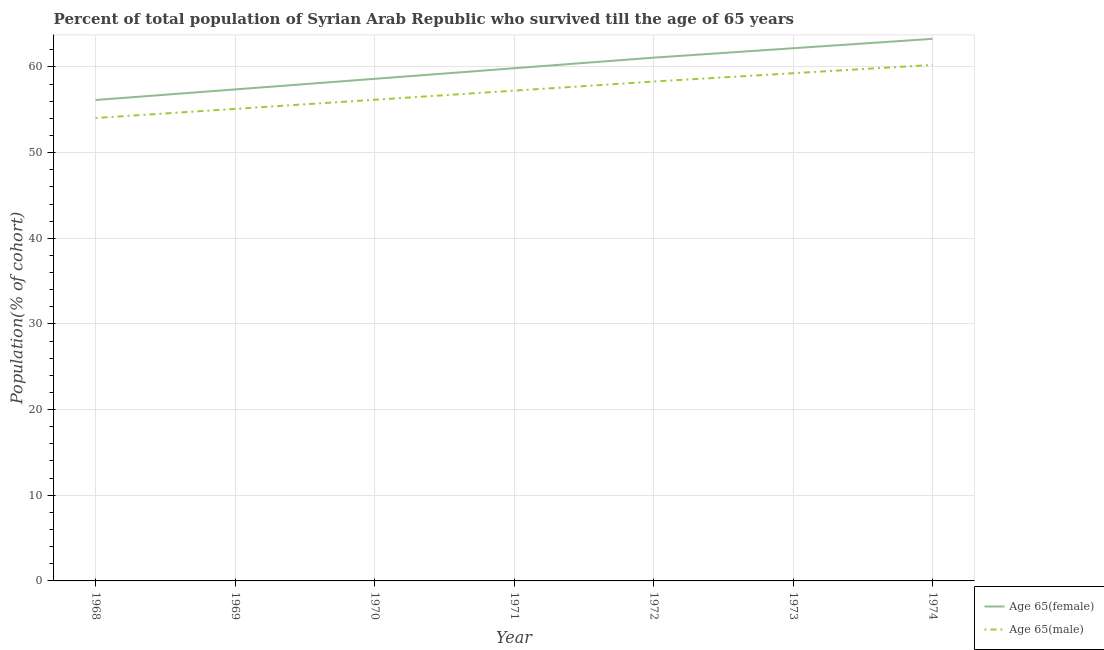Is the number of lines equal to the number of legend labels?
Provide a succinct answer. Yes. What is the percentage of male population who survived till age of 65 in 1974?
Provide a short and direct response. 60.24. Across all years, what is the maximum percentage of female population who survived till age of 65?
Provide a short and direct response. 63.28. Across all years, what is the minimum percentage of female population who survived till age of 65?
Your answer should be very brief. 56.14. In which year was the percentage of male population who survived till age of 65 maximum?
Your answer should be very brief. 1974. In which year was the percentage of male population who survived till age of 65 minimum?
Your response must be concise. 1968. What is the total percentage of female population who survived till age of 65 in the graph?
Your answer should be compact. 418.53. What is the difference between the percentage of male population who survived till age of 65 in 1972 and that in 1973?
Your answer should be very brief. -0.97. What is the difference between the percentage of female population who survived till age of 65 in 1971 and the percentage of male population who survived till age of 65 in 1970?
Provide a succinct answer. 3.68. What is the average percentage of female population who survived till age of 65 per year?
Provide a short and direct response. 59.79. In the year 1968, what is the difference between the percentage of male population who survived till age of 65 and percentage of female population who survived till age of 65?
Make the answer very short. -2.1. In how many years, is the percentage of male population who survived till age of 65 greater than 24 %?
Provide a short and direct response. 7. What is the ratio of the percentage of male population who survived till age of 65 in 1968 to that in 1969?
Provide a short and direct response. 0.98. Is the percentage of female population who survived till age of 65 in 1970 less than that in 1972?
Offer a very short reply. Yes. What is the difference between the highest and the second highest percentage of male population who survived till age of 65?
Offer a very short reply. 0.97. What is the difference between the highest and the lowest percentage of female population who survived till age of 65?
Your response must be concise. 7.14. In how many years, is the percentage of male population who survived till age of 65 greater than the average percentage of male population who survived till age of 65 taken over all years?
Provide a short and direct response. 4. Is the sum of the percentage of female population who survived till age of 65 in 1968 and 1970 greater than the maximum percentage of male population who survived till age of 65 across all years?
Your answer should be very brief. Yes. Does the percentage of female population who survived till age of 65 monotonically increase over the years?
Give a very brief answer. Yes. Is the percentage of female population who survived till age of 65 strictly greater than the percentage of male population who survived till age of 65 over the years?
Keep it short and to the point. Yes. Is the percentage of male population who survived till age of 65 strictly less than the percentage of female population who survived till age of 65 over the years?
Your answer should be compact. Yes. What is the difference between two consecutive major ticks on the Y-axis?
Provide a succinct answer. 10. Does the graph contain any zero values?
Offer a terse response. No. How many legend labels are there?
Keep it short and to the point. 2. How are the legend labels stacked?
Offer a terse response. Vertical. What is the title of the graph?
Your answer should be very brief. Percent of total population of Syrian Arab Republic who survived till the age of 65 years. Does "State government" appear as one of the legend labels in the graph?
Make the answer very short. No. What is the label or title of the Y-axis?
Make the answer very short. Population(% of cohort). What is the Population(% of cohort) of Age 65(female) in 1968?
Offer a very short reply. 56.14. What is the Population(% of cohort) of Age 65(male) in 1968?
Make the answer very short. 54.04. What is the Population(% of cohort) of Age 65(female) in 1969?
Provide a short and direct response. 57.38. What is the Population(% of cohort) in Age 65(male) in 1969?
Keep it short and to the point. 55.11. What is the Population(% of cohort) of Age 65(female) in 1970?
Ensure brevity in your answer.  58.61. What is the Population(% of cohort) in Age 65(male) in 1970?
Provide a short and direct response. 56.17. What is the Population(% of cohort) in Age 65(female) in 1971?
Ensure brevity in your answer.  59.85. What is the Population(% of cohort) of Age 65(male) in 1971?
Provide a succinct answer. 57.23. What is the Population(% of cohort) of Age 65(female) in 1972?
Offer a very short reply. 61.09. What is the Population(% of cohort) in Age 65(male) in 1972?
Provide a short and direct response. 58.3. What is the Population(% of cohort) of Age 65(female) in 1973?
Keep it short and to the point. 62.18. What is the Population(% of cohort) of Age 65(male) in 1973?
Provide a succinct answer. 59.27. What is the Population(% of cohort) in Age 65(female) in 1974?
Give a very brief answer. 63.28. What is the Population(% of cohort) of Age 65(male) in 1974?
Your response must be concise. 60.24. Across all years, what is the maximum Population(% of cohort) in Age 65(female)?
Give a very brief answer. 63.28. Across all years, what is the maximum Population(% of cohort) in Age 65(male)?
Give a very brief answer. 60.24. Across all years, what is the minimum Population(% of cohort) in Age 65(female)?
Offer a very short reply. 56.14. Across all years, what is the minimum Population(% of cohort) in Age 65(male)?
Your answer should be very brief. 54.04. What is the total Population(% of cohort) of Age 65(female) in the graph?
Give a very brief answer. 418.53. What is the total Population(% of cohort) of Age 65(male) in the graph?
Your answer should be very brief. 400.35. What is the difference between the Population(% of cohort) of Age 65(female) in 1968 and that in 1969?
Give a very brief answer. -1.24. What is the difference between the Population(% of cohort) in Age 65(male) in 1968 and that in 1969?
Provide a short and direct response. -1.06. What is the difference between the Population(% of cohort) in Age 65(female) in 1968 and that in 1970?
Keep it short and to the point. -2.47. What is the difference between the Population(% of cohort) of Age 65(male) in 1968 and that in 1970?
Make the answer very short. -2.13. What is the difference between the Population(% of cohort) of Age 65(female) in 1968 and that in 1971?
Keep it short and to the point. -3.71. What is the difference between the Population(% of cohort) of Age 65(male) in 1968 and that in 1971?
Ensure brevity in your answer.  -3.19. What is the difference between the Population(% of cohort) of Age 65(female) in 1968 and that in 1972?
Make the answer very short. -4.94. What is the difference between the Population(% of cohort) of Age 65(male) in 1968 and that in 1972?
Your answer should be very brief. -4.25. What is the difference between the Population(% of cohort) in Age 65(female) in 1968 and that in 1973?
Provide a short and direct response. -6.04. What is the difference between the Population(% of cohort) in Age 65(male) in 1968 and that in 1973?
Keep it short and to the point. -5.23. What is the difference between the Population(% of cohort) of Age 65(female) in 1968 and that in 1974?
Offer a very short reply. -7.14. What is the difference between the Population(% of cohort) in Age 65(male) in 1968 and that in 1974?
Keep it short and to the point. -6.2. What is the difference between the Population(% of cohort) of Age 65(female) in 1969 and that in 1970?
Ensure brevity in your answer.  -1.24. What is the difference between the Population(% of cohort) of Age 65(male) in 1969 and that in 1970?
Your response must be concise. -1.06. What is the difference between the Population(% of cohort) of Age 65(female) in 1969 and that in 1971?
Provide a short and direct response. -2.47. What is the difference between the Population(% of cohort) in Age 65(male) in 1969 and that in 1971?
Keep it short and to the point. -2.13. What is the difference between the Population(% of cohort) in Age 65(female) in 1969 and that in 1972?
Offer a terse response. -3.71. What is the difference between the Population(% of cohort) of Age 65(male) in 1969 and that in 1972?
Your answer should be compact. -3.19. What is the difference between the Population(% of cohort) in Age 65(female) in 1969 and that in 1973?
Offer a terse response. -4.81. What is the difference between the Population(% of cohort) in Age 65(male) in 1969 and that in 1973?
Keep it short and to the point. -4.16. What is the difference between the Population(% of cohort) in Age 65(female) in 1969 and that in 1974?
Provide a succinct answer. -5.91. What is the difference between the Population(% of cohort) of Age 65(male) in 1969 and that in 1974?
Your response must be concise. -5.13. What is the difference between the Population(% of cohort) of Age 65(female) in 1970 and that in 1971?
Your response must be concise. -1.24. What is the difference between the Population(% of cohort) of Age 65(male) in 1970 and that in 1971?
Your answer should be compact. -1.06. What is the difference between the Population(% of cohort) of Age 65(female) in 1970 and that in 1972?
Offer a terse response. -2.47. What is the difference between the Population(% of cohort) in Age 65(male) in 1970 and that in 1972?
Offer a very short reply. -2.13. What is the difference between the Population(% of cohort) of Age 65(female) in 1970 and that in 1973?
Give a very brief answer. -3.57. What is the difference between the Population(% of cohort) of Age 65(male) in 1970 and that in 1973?
Your answer should be very brief. -3.1. What is the difference between the Population(% of cohort) in Age 65(female) in 1970 and that in 1974?
Your answer should be compact. -4.67. What is the difference between the Population(% of cohort) of Age 65(male) in 1970 and that in 1974?
Keep it short and to the point. -4.07. What is the difference between the Population(% of cohort) of Age 65(female) in 1971 and that in 1972?
Offer a very short reply. -1.24. What is the difference between the Population(% of cohort) in Age 65(male) in 1971 and that in 1972?
Ensure brevity in your answer.  -1.06. What is the difference between the Population(% of cohort) of Age 65(female) in 1971 and that in 1973?
Ensure brevity in your answer.  -2.33. What is the difference between the Population(% of cohort) in Age 65(male) in 1971 and that in 1973?
Offer a terse response. -2.04. What is the difference between the Population(% of cohort) in Age 65(female) in 1971 and that in 1974?
Ensure brevity in your answer.  -3.43. What is the difference between the Population(% of cohort) in Age 65(male) in 1971 and that in 1974?
Offer a very short reply. -3.01. What is the difference between the Population(% of cohort) in Age 65(female) in 1972 and that in 1973?
Provide a short and direct response. -1.1. What is the difference between the Population(% of cohort) of Age 65(male) in 1972 and that in 1973?
Your response must be concise. -0.97. What is the difference between the Population(% of cohort) in Age 65(female) in 1972 and that in 1974?
Make the answer very short. -2.2. What is the difference between the Population(% of cohort) in Age 65(male) in 1972 and that in 1974?
Give a very brief answer. -1.94. What is the difference between the Population(% of cohort) in Age 65(female) in 1973 and that in 1974?
Provide a short and direct response. -1.1. What is the difference between the Population(% of cohort) of Age 65(male) in 1973 and that in 1974?
Your response must be concise. -0.97. What is the difference between the Population(% of cohort) of Age 65(female) in 1968 and the Population(% of cohort) of Age 65(male) in 1969?
Your response must be concise. 1.03. What is the difference between the Population(% of cohort) of Age 65(female) in 1968 and the Population(% of cohort) of Age 65(male) in 1970?
Keep it short and to the point. -0.03. What is the difference between the Population(% of cohort) in Age 65(female) in 1968 and the Population(% of cohort) in Age 65(male) in 1971?
Provide a short and direct response. -1.09. What is the difference between the Population(% of cohort) in Age 65(female) in 1968 and the Population(% of cohort) in Age 65(male) in 1972?
Provide a succinct answer. -2.15. What is the difference between the Population(% of cohort) of Age 65(female) in 1968 and the Population(% of cohort) of Age 65(male) in 1973?
Give a very brief answer. -3.13. What is the difference between the Population(% of cohort) of Age 65(female) in 1968 and the Population(% of cohort) of Age 65(male) in 1974?
Offer a very short reply. -4.1. What is the difference between the Population(% of cohort) in Age 65(female) in 1969 and the Population(% of cohort) in Age 65(male) in 1970?
Your answer should be compact. 1.21. What is the difference between the Population(% of cohort) of Age 65(female) in 1969 and the Population(% of cohort) of Age 65(male) in 1971?
Your response must be concise. 0.14. What is the difference between the Population(% of cohort) in Age 65(female) in 1969 and the Population(% of cohort) in Age 65(male) in 1972?
Provide a short and direct response. -0.92. What is the difference between the Population(% of cohort) of Age 65(female) in 1969 and the Population(% of cohort) of Age 65(male) in 1973?
Offer a very short reply. -1.89. What is the difference between the Population(% of cohort) in Age 65(female) in 1969 and the Population(% of cohort) in Age 65(male) in 1974?
Provide a short and direct response. -2.86. What is the difference between the Population(% of cohort) of Age 65(female) in 1970 and the Population(% of cohort) of Age 65(male) in 1971?
Your response must be concise. 1.38. What is the difference between the Population(% of cohort) in Age 65(female) in 1970 and the Population(% of cohort) in Age 65(male) in 1972?
Your answer should be very brief. 0.32. What is the difference between the Population(% of cohort) in Age 65(female) in 1970 and the Population(% of cohort) in Age 65(male) in 1973?
Make the answer very short. -0.65. What is the difference between the Population(% of cohort) of Age 65(female) in 1970 and the Population(% of cohort) of Age 65(male) in 1974?
Your response must be concise. -1.63. What is the difference between the Population(% of cohort) in Age 65(female) in 1971 and the Population(% of cohort) in Age 65(male) in 1972?
Ensure brevity in your answer.  1.55. What is the difference between the Population(% of cohort) of Age 65(female) in 1971 and the Population(% of cohort) of Age 65(male) in 1973?
Ensure brevity in your answer.  0.58. What is the difference between the Population(% of cohort) of Age 65(female) in 1971 and the Population(% of cohort) of Age 65(male) in 1974?
Offer a terse response. -0.39. What is the difference between the Population(% of cohort) of Age 65(female) in 1972 and the Population(% of cohort) of Age 65(male) in 1973?
Offer a terse response. 1.82. What is the difference between the Population(% of cohort) in Age 65(female) in 1972 and the Population(% of cohort) in Age 65(male) in 1974?
Your answer should be very brief. 0.84. What is the difference between the Population(% of cohort) in Age 65(female) in 1973 and the Population(% of cohort) in Age 65(male) in 1974?
Keep it short and to the point. 1.94. What is the average Population(% of cohort) in Age 65(female) per year?
Your answer should be compact. 59.79. What is the average Population(% of cohort) of Age 65(male) per year?
Your response must be concise. 57.19. In the year 1968, what is the difference between the Population(% of cohort) of Age 65(female) and Population(% of cohort) of Age 65(male)?
Offer a terse response. 2.1. In the year 1969, what is the difference between the Population(% of cohort) of Age 65(female) and Population(% of cohort) of Age 65(male)?
Give a very brief answer. 2.27. In the year 1970, what is the difference between the Population(% of cohort) in Age 65(female) and Population(% of cohort) in Age 65(male)?
Your answer should be very brief. 2.44. In the year 1971, what is the difference between the Population(% of cohort) in Age 65(female) and Population(% of cohort) in Age 65(male)?
Offer a very short reply. 2.62. In the year 1972, what is the difference between the Population(% of cohort) in Age 65(female) and Population(% of cohort) in Age 65(male)?
Keep it short and to the point. 2.79. In the year 1973, what is the difference between the Population(% of cohort) in Age 65(female) and Population(% of cohort) in Age 65(male)?
Keep it short and to the point. 2.92. In the year 1974, what is the difference between the Population(% of cohort) of Age 65(female) and Population(% of cohort) of Age 65(male)?
Offer a very short reply. 3.04. What is the ratio of the Population(% of cohort) of Age 65(female) in 1968 to that in 1969?
Provide a succinct answer. 0.98. What is the ratio of the Population(% of cohort) in Age 65(male) in 1968 to that in 1969?
Offer a terse response. 0.98. What is the ratio of the Population(% of cohort) in Age 65(female) in 1968 to that in 1970?
Give a very brief answer. 0.96. What is the ratio of the Population(% of cohort) of Age 65(male) in 1968 to that in 1970?
Your answer should be very brief. 0.96. What is the ratio of the Population(% of cohort) of Age 65(female) in 1968 to that in 1971?
Give a very brief answer. 0.94. What is the ratio of the Population(% of cohort) in Age 65(male) in 1968 to that in 1971?
Give a very brief answer. 0.94. What is the ratio of the Population(% of cohort) in Age 65(female) in 1968 to that in 1972?
Your answer should be very brief. 0.92. What is the ratio of the Population(% of cohort) of Age 65(male) in 1968 to that in 1972?
Ensure brevity in your answer.  0.93. What is the ratio of the Population(% of cohort) of Age 65(female) in 1968 to that in 1973?
Make the answer very short. 0.9. What is the ratio of the Population(% of cohort) of Age 65(male) in 1968 to that in 1973?
Your answer should be compact. 0.91. What is the ratio of the Population(% of cohort) of Age 65(female) in 1968 to that in 1974?
Keep it short and to the point. 0.89. What is the ratio of the Population(% of cohort) in Age 65(male) in 1968 to that in 1974?
Your answer should be very brief. 0.9. What is the ratio of the Population(% of cohort) of Age 65(female) in 1969 to that in 1970?
Offer a very short reply. 0.98. What is the ratio of the Population(% of cohort) of Age 65(male) in 1969 to that in 1970?
Provide a succinct answer. 0.98. What is the ratio of the Population(% of cohort) in Age 65(female) in 1969 to that in 1971?
Your response must be concise. 0.96. What is the ratio of the Population(% of cohort) in Age 65(male) in 1969 to that in 1971?
Ensure brevity in your answer.  0.96. What is the ratio of the Population(% of cohort) in Age 65(female) in 1969 to that in 1972?
Provide a short and direct response. 0.94. What is the ratio of the Population(% of cohort) of Age 65(male) in 1969 to that in 1972?
Give a very brief answer. 0.95. What is the ratio of the Population(% of cohort) of Age 65(female) in 1969 to that in 1973?
Offer a terse response. 0.92. What is the ratio of the Population(% of cohort) in Age 65(male) in 1969 to that in 1973?
Provide a succinct answer. 0.93. What is the ratio of the Population(% of cohort) of Age 65(female) in 1969 to that in 1974?
Ensure brevity in your answer.  0.91. What is the ratio of the Population(% of cohort) in Age 65(male) in 1969 to that in 1974?
Keep it short and to the point. 0.91. What is the ratio of the Population(% of cohort) in Age 65(female) in 1970 to that in 1971?
Your answer should be very brief. 0.98. What is the ratio of the Population(% of cohort) in Age 65(male) in 1970 to that in 1971?
Your answer should be compact. 0.98. What is the ratio of the Population(% of cohort) of Age 65(female) in 1970 to that in 1972?
Your answer should be very brief. 0.96. What is the ratio of the Population(% of cohort) of Age 65(male) in 1970 to that in 1972?
Your response must be concise. 0.96. What is the ratio of the Population(% of cohort) in Age 65(female) in 1970 to that in 1973?
Ensure brevity in your answer.  0.94. What is the ratio of the Population(% of cohort) of Age 65(male) in 1970 to that in 1973?
Provide a short and direct response. 0.95. What is the ratio of the Population(% of cohort) of Age 65(female) in 1970 to that in 1974?
Give a very brief answer. 0.93. What is the ratio of the Population(% of cohort) in Age 65(male) in 1970 to that in 1974?
Your answer should be compact. 0.93. What is the ratio of the Population(% of cohort) in Age 65(female) in 1971 to that in 1972?
Give a very brief answer. 0.98. What is the ratio of the Population(% of cohort) of Age 65(male) in 1971 to that in 1972?
Your response must be concise. 0.98. What is the ratio of the Population(% of cohort) in Age 65(female) in 1971 to that in 1973?
Keep it short and to the point. 0.96. What is the ratio of the Population(% of cohort) of Age 65(male) in 1971 to that in 1973?
Provide a succinct answer. 0.97. What is the ratio of the Population(% of cohort) in Age 65(female) in 1971 to that in 1974?
Your answer should be compact. 0.95. What is the ratio of the Population(% of cohort) in Age 65(male) in 1971 to that in 1974?
Your response must be concise. 0.95. What is the ratio of the Population(% of cohort) of Age 65(female) in 1972 to that in 1973?
Ensure brevity in your answer.  0.98. What is the ratio of the Population(% of cohort) in Age 65(male) in 1972 to that in 1973?
Keep it short and to the point. 0.98. What is the ratio of the Population(% of cohort) in Age 65(female) in 1972 to that in 1974?
Provide a short and direct response. 0.97. What is the ratio of the Population(% of cohort) in Age 65(female) in 1973 to that in 1974?
Offer a very short reply. 0.98. What is the ratio of the Population(% of cohort) of Age 65(male) in 1973 to that in 1974?
Offer a terse response. 0.98. What is the difference between the highest and the second highest Population(% of cohort) of Age 65(female)?
Your response must be concise. 1.1. What is the difference between the highest and the second highest Population(% of cohort) of Age 65(male)?
Provide a succinct answer. 0.97. What is the difference between the highest and the lowest Population(% of cohort) in Age 65(female)?
Your response must be concise. 7.14. What is the difference between the highest and the lowest Population(% of cohort) in Age 65(male)?
Your answer should be very brief. 6.2. 